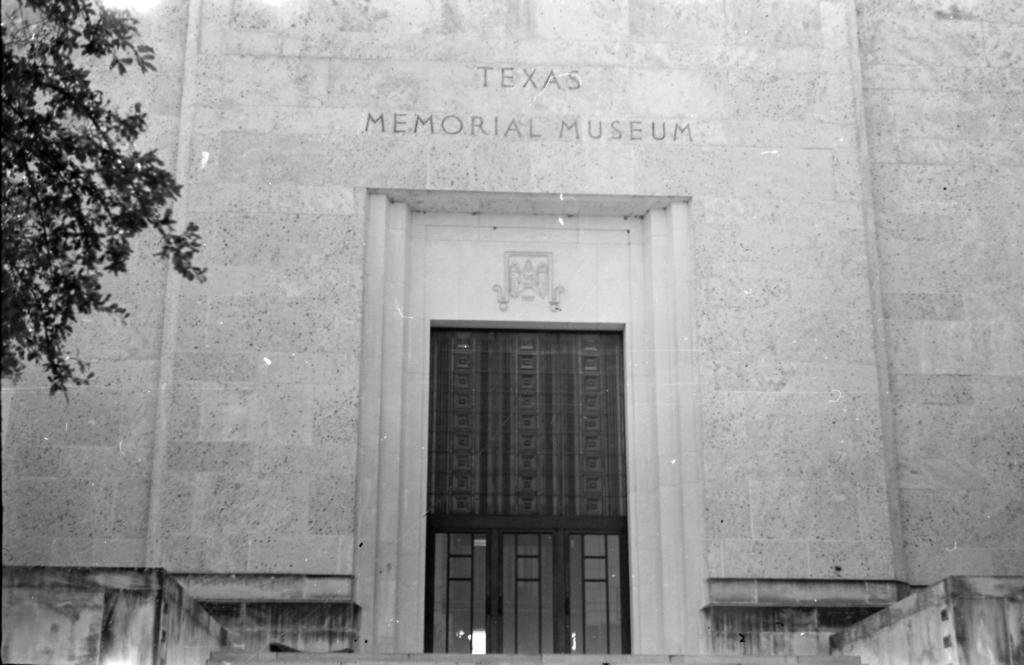What is the color scheme of the image? The image is black and white. What can be seen on the left side of the image? There is a tree on the left side of the image. What is visible in the background of the image? There is a building, a door, and text written on a wall in the background of the image. What type of bell can be heard ringing in the image? There is no bell present in the image, and therefore no sound can be heard. What type of secretary is working in the building in the image? There is no indication of a secretary or any people working in the building in the image. 